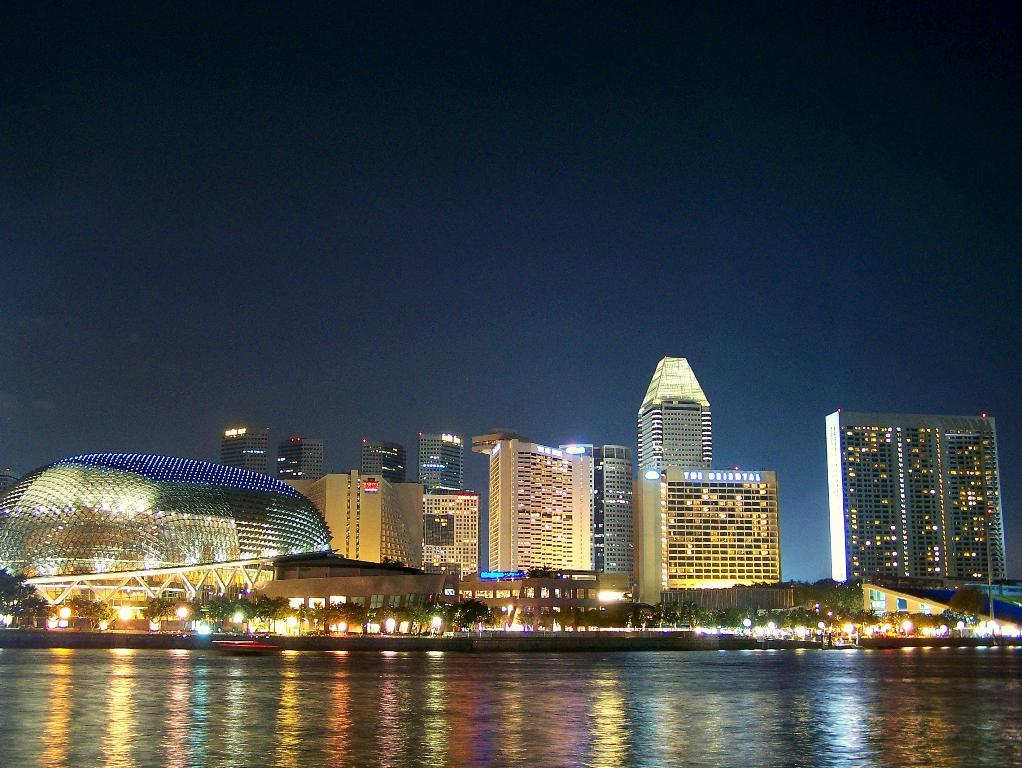What is the primary element visible in the image? There is water in the image. What can be seen in the distance behind the water? There are buildings, trees, and lights visible in the background of the image. Can you describe the text or writing present in the image? Unfortunately, the specific content of the text or writing cannot be determined from the provided facts. What type of transport system can be seen in the image? There is no transport system visible in the image; it primarily features water, buildings, trees, and lights in the background. 